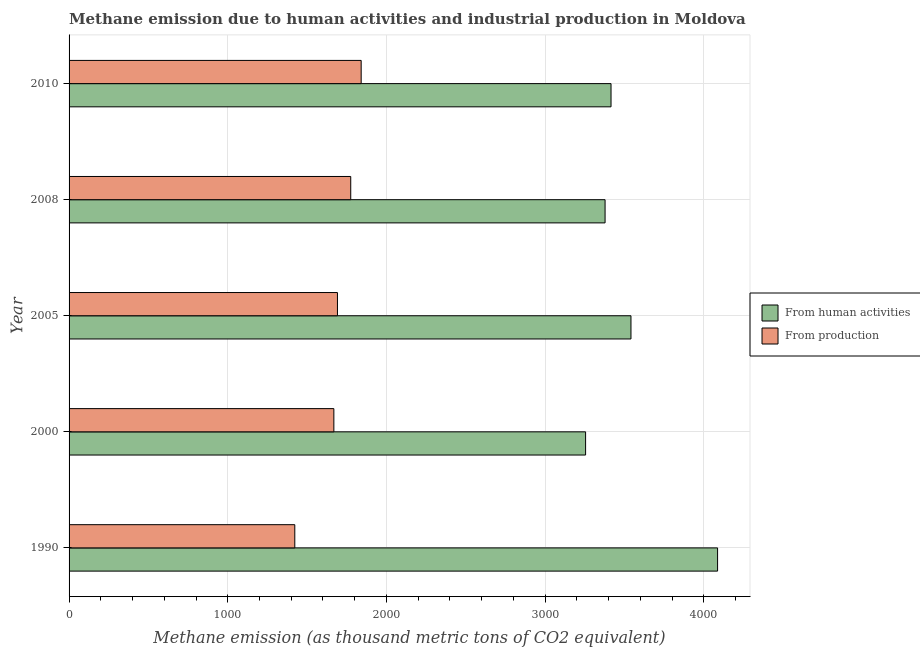How many different coloured bars are there?
Offer a terse response. 2. Are the number of bars on each tick of the Y-axis equal?
Your answer should be compact. Yes. How many bars are there on the 1st tick from the bottom?
Ensure brevity in your answer.  2. In how many cases, is the number of bars for a given year not equal to the number of legend labels?
Your answer should be very brief. 0. What is the amount of emissions from human activities in 1990?
Provide a succinct answer. 4086.4. Across all years, what is the maximum amount of emissions generated from industries?
Offer a terse response. 1840.6. Across all years, what is the minimum amount of emissions from human activities?
Give a very brief answer. 3254.7. What is the total amount of emissions generated from industries in the graph?
Your answer should be very brief. 8397.3. What is the difference between the amount of emissions generated from industries in 1990 and that in 2010?
Ensure brevity in your answer.  -418.3. What is the difference between the amount of emissions generated from industries in 2005 and the amount of emissions from human activities in 2008?
Make the answer very short. -1686.4. What is the average amount of emissions from human activities per year?
Your answer should be compact. 3534.84. In the year 2000, what is the difference between the amount of emissions from human activities and amount of emissions generated from industries?
Make the answer very short. 1586.2. Is the difference between the amount of emissions generated from industries in 2008 and 2010 greater than the difference between the amount of emissions from human activities in 2008 and 2010?
Your response must be concise. No. What is the difference between the highest and the second highest amount of emissions from human activities?
Offer a very short reply. 545.8. What is the difference between the highest and the lowest amount of emissions from human activities?
Ensure brevity in your answer.  831.7. In how many years, is the amount of emissions generated from industries greater than the average amount of emissions generated from industries taken over all years?
Ensure brevity in your answer.  3. What does the 1st bar from the top in 2008 represents?
Provide a succinct answer. From production. What does the 2nd bar from the bottom in 2008 represents?
Make the answer very short. From production. Are all the bars in the graph horizontal?
Give a very brief answer. Yes. How many years are there in the graph?
Provide a succinct answer. 5. What is the difference between two consecutive major ticks on the X-axis?
Give a very brief answer. 1000. Are the values on the major ticks of X-axis written in scientific E-notation?
Ensure brevity in your answer.  No. Does the graph contain grids?
Provide a succinct answer. Yes. How many legend labels are there?
Offer a terse response. 2. What is the title of the graph?
Provide a short and direct response. Methane emission due to human activities and industrial production in Moldova. What is the label or title of the X-axis?
Your answer should be compact. Methane emission (as thousand metric tons of CO2 equivalent). What is the Methane emission (as thousand metric tons of CO2 equivalent) in From human activities in 1990?
Provide a short and direct response. 4086.4. What is the Methane emission (as thousand metric tons of CO2 equivalent) of From production in 1990?
Your response must be concise. 1422.3. What is the Methane emission (as thousand metric tons of CO2 equivalent) of From human activities in 2000?
Ensure brevity in your answer.  3254.7. What is the Methane emission (as thousand metric tons of CO2 equivalent) of From production in 2000?
Offer a very short reply. 1668.5. What is the Methane emission (as thousand metric tons of CO2 equivalent) in From human activities in 2005?
Give a very brief answer. 3540.6. What is the Methane emission (as thousand metric tons of CO2 equivalent) in From production in 2005?
Provide a succinct answer. 1691.1. What is the Methane emission (as thousand metric tons of CO2 equivalent) of From human activities in 2008?
Keep it short and to the point. 3377.5. What is the Methane emission (as thousand metric tons of CO2 equivalent) of From production in 2008?
Keep it short and to the point. 1774.8. What is the Methane emission (as thousand metric tons of CO2 equivalent) in From human activities in 2010?
Keep it short and to the point. 3415. What is the Methane emission (as thousand metric tons of CO2 equivalent) in From production in 2010?
Keep it short and to the point. 1840.6. Across all years, what is the maximum Methane emission (as thousand metric tons of CO2 equivalent) in From human activities?
Your answer should be compact. 4086.4. Across all years, what is the maximum Methane emission (as thousand metric tons of CO2 equivalent) in From production?
Provide a short and direct response. 1840.6. Across all years, what is the minimum Methane emission (as thousand metric tons of CO2 equivalent) in From human activities?
Your answer should be very brief. 3254.7. Across all years, what is the minimum Methane emission (as thousand metric tons of CO2 equivalent) in From production?
Your answer should be compact. 1422.3. What is the total Methane emission (as thousand metric tons of CO2 equivalent) of From human activities in the graph?
Your answer should be compact. 1.77e+04. What is the total Methane emission (as thousand metric tons of CO2 equivalent) of From production in the graph?
Provide a short and direct response. 8397.3. What is the difference between the Methane emission (as thousand metric tons of CO2 equivalent) of From human activities in 1990 and that in 2000?
Ensure brevity in your answer.  831.7. What is the difference between the Methane emission (as thousand metric tons of CO2 equivalent) of From production in 1990 and that in 2000?
Your response must be concise. -246.2. What is the difference between the Methane emission (as thousand metric tons of CO2 equivalent) of From human activities in 1990 and that in 2005?
Offer a very short reply. 545.8. What is the difference between the Methane emission (as thousand metric tons of CO2 equivalent) of From production in 1990 and that in 2005?
Ensure brevity in your answer.  -268.8. What is the difference between the Methane emission (as thousand metric tons of CO2 equivalent) in From human activities in 1990 and that in 2008?
Your response must be concise. 708.9. What is the difference between the Methane emission (as thousand metric tons of CO2 equivalent) of From production in 1990 and that in 2008?
Provide a succinct answer. -352.5. What is the difference between the Methane emission (as thousand metric tons of CO2 equivalent) in From human activities in 1990 and that in 2010?
Your answer should be compact. 671.4. What is the difference between the Methane emission (as thousand metric tons of CO2 equivalent) of From production in 1990 and that in 2010?
Offer a terse response. -418.3. What is the difference between the Methane emission (as thousand metric tons of CO2 equivalent) in From human activities in 2000 and that in 2005?
Provide a short and direct response. -285.9. What is the difference between the Methane emission (as thousand metric tons of CO2 equivalent) of From production in 2000 and that in 2005?
Offer a terse response. -22.6. What is the difference between the Methane emission (as thousand metric tons of CO2 equivalent) in From human activities in 2000 and that in 2008?
Provide a succinct answer. -122.8. What is the difference between the Methane emission (as thousand metric tons of CO2 equivalent) of From production in 2000 and that in 2008?
Offer a terse response. -106.3. What is the difference between the Methane emission (as thousand metric tons of CO2 equivalent) of From human activities in 2000 and that in 2010?
Your answer should be compact. -160.3. What is the difference between the Methane emission (as thousand metric tons of CO2 equivalent) of From production in 2000 and that in 2010?
Provide a succinct answer. -172.1. What is the difference between the Methane emission (as thousand metric tons of CO2 equivalent) of From human activities in 2005 and that in 2008?
Keep it short and to the point. 163.1. What is the difference between the Methane emission (as thousand metric tons of CO2 equivalent) of From production in 2005 and that in 2008?
Your answer should be compact. -83.7. What is the difference between the Methane emission (as thousand metric tons of CO2 equivalent) in From human activities in 2005 and that in 2010?
Give a very brief answer. 125.6. What is the difference between the Methane emission (as thousand metric tons of CO2 equivalent) in From production in 2005 and that in 2010?
Your answer should be compact. -149.5. What is the difference between the Methane emission (as thousand metric tons of CO2 equivalent) in From human activities in 2008 and that in 2010?
Give a very brief answer. -37.5. What is the difference between the Methane emission (as thousand metric tons of CO2 equivalent) in From production in 2008 and that in 2010?
Keep it short and to the point. -65.8. What is the difference between the Methane emission (as thousand metric tons of CO2 equivalent) of From human activities in 1990 and the Methane emission (as thousand metric tons of CO2 equivalent) of From production in 2000?
Make the answer very short. 2417.9. What is the difference between the Methane emission (as thousand metric tons of CO2 equivalent) in From human activities in 1990 and the Methane emission (as thousand metric tons of CO2 equivalent) in From production in 2005?
Make the answer very short. 2395.3. What is the difference between the Methane emission (as thousand metric tons of CO2 equivalent) of From human activities in 1990 and the Methane emission (as thousand metric tons of CO2 equivalent) of From production in 2008?
Make the answer very short. 2311.6. What is the difference between the Methane emission (as thousand metric tons of CO2 equivalent) in From human activities in 1990 and the Methane emission (as thousand metric tons of CO2 equivalent) in From production in 2010?
Your answer should be compact. 2245.8. What is the difference between the Methane emission (as thousand metric tons of CO2 equivalent) in From human activities in 2000 and the Methane emission (as thousand metric tons of CO2 equivalent) in From production in 2005?
Your response must be concise. 1563.6. What is the difference between the Methane emission (as thousand metric tons of CO2 equivalent) in From human activities in 2000 and the Methane emission (as thousand metric tons of CO2 equivalent) in From production in 2008?
Offer a terse response. 1479.9. What is the difference between the Methane emission (as thousand metric tons of CO2 equivalent) in From human activities in 2000 and the Methane emission (as thousand metric tons of CO2 equivalent) in From production in 2010?
Make the answer very short. 1414.1. What is the difference between the Methane emission (as thousand metric tons of CO2 equivalent) of From human activities in 2005 and the Methane emission (as thousand metric tons of CO2 equivalent) of From production in 2008?
Provide a succinct answer. 1765.8. What is the difference between the Methane emission (as thousand metric tons of CO2 equivalent) in From human activities in 2005 and the Methane emission (as thousand metric tons of CO2 equivalent) in From production in 2010?
Make the answer very short. 1700. What is the difference between the Methane emission (as thousand metric tons of CO2 equivalent) in From human activities in 2008 and the Methane emission (as thousand metric tons of CO2 equivalent) in From production in 2010?
Give a very brief answer. 1536.9. What is the average Methane emission (as thousand metric tons of CO2 equivalent) of From human activities per year?
Provide a succinct answer. 3534.84. What is the average Methane emission (as thousand metric tons of CO2 equivalent) of From production per year?
Keep it short and to the point. 1679.46. In the year 1990, what is the difference between the Methane emission (as thousand metric tons of CO2 equivalent) of From human activities and Methane emission (as thousand metric tons of CO2 equivalent) of From production?
Provide a succinct answer. 2664.1. In the year 2000, what is the difference between the Methane emission (as thousand metric tons of CO2 equivalent) of From human activities and Methane emission (as thousand metric tons of CO2 equivalent) of From production?
Keep it short and to the point. 1586.2. In the year 2005, what is the difference between the Methane emission (as thousand metric tons of CO2 equivalent) of From human activities and Methane emission (as thousand metric tons of CO2 equivalent) of From production?
Offer a very short reply. 1849.5. In the year 2008, what is the difference between the Methane emission (as thousand metric tons of CO2 equivalent) of From human activities and Methane emission (as thousand metric tons of CO2 equivalent) of From production?
Offer a terse response. 1602.7. In the year 2010, what is the difference between the Methane emission (as thousand metric tons of CO2 equivalent) of From human activities and Methane emission (as thousand metric tons of CO2 equivalent) of From production?
Your answer should be compact. 1574.4. What is the ratio of the Methane emission (as thousand metric tons of CO2 equivalent) in From human activities in 1990 to that in 2000?
Provide a succinct answer. 1.26. What is the ratio of the Methane emission (as thousand metric tons of CO2 equivalent) of From production in 1990 to that in 2000?
Your response must be concise. 0.85. What is the ratio of the Methane emission (as thousand metric tons of CO2 equivalent) in From human activities in 1990 to that in 2005?
Your answer should be compact. 1.15. What is the ratio of the Methane emission (as thousand metric tons of CO2 equivalent) in From production in 1990 to that in 2005?
Make the answer very short. 0.84. What is the ratio of the Methane emission (as thousand metric tons of CO2 equivalent) in From human activities in 1990 to that in 2008?
Make the answer very short. 1.21. What is the ratio of the Methane emission (as thousand metric tons of CO2 equivalent) of From production in 1990 to that in 2008?
Your answer should be compact. 0.8. What is the ratio of the Methane emission (as thousand metric tons of CO2 equivalent) in From human activities in 1990 to that in 2010?
Offer a very short reply. 1.2. What is the ratio of the Methane emission (as thousand metric tons of CO2 equivalent) in From production in 1990 to that in 2010?
Make the answer very short. 0.77. What is the ratio of the Methane emission (as thousand metric tons of CO2 equivalent) in From human activities in 2000 to that in 2005?
Provide a succinct answer. 0.92. What is the ratio of the Methane emission (as thousand metric tons of CO2 equivalent) in From production in 2000 to that in 2005?
Your response must be concise. 0.99. What is the ratio of the Methane emission (as thousand metric tons of CO2 equivalent) of From human activities in 2000 to that in 2008?
Your answer should be very brief. 0.96. What is the ratio of the Methane emission (as thousand metric tons of CO2 equivalent) of From production in 2000 to that in 2008?
Your answer should be very brief. 0.94. What is the ratio of the Methane emission (as thousand metric tons of CO2 equivalent) of From human activities in 2000 to that in 2010?
Provide a succinct answer. 0.95. What is the ratio of the Methane emission (as thousand metric tons of CO2 equivalent) in From production in 2000 to that in 2010?
Your answer should be compact. 0.91. What is the ratio of the Methane emission (as thousand metric tons of CO2 equivalent) of From human activities in 2005 to that in 2008?
Your answer should be compact. 1.05. What is the ratio of the Methane emission (as thousand metric tons of CO2 equivalent) in From production in 2005 to that in 2008?
Your answer should be compact. 0.95. What is the ratio of the Methane emission (as thousand metric tons of CO2 equivalent) of From human activities in 2005 to that in 2010?
Offer a very short reply. 1.04. What is the ratio of the Methane emission (as thousand metric tons of CO2 equivalent) in From production in 2005 to that in 2010?
Provide a short and direct response. 0.92. What is the difference between the highest and the second highest Methane emission (as thousand metric tons of CO2 equivalent) in From human activities?
Offer a terse response. 545.8. What is the difference between the highest and the second highest Methane emission (as thousand metric tons of CO2 equivalent) in From production?
Provide a succinct answer. 65.8. What is the difference between the highest and the lowest Methane emission (as thousand metric tons of CO2 equivalent) in From human activities?
Your answer should be compact. 831.7. What is the difference between the highest and the lowest Methane emission (as thousand metric tons of CO2 equivalent) in From production?
Offer a very short reply. 418.3. 